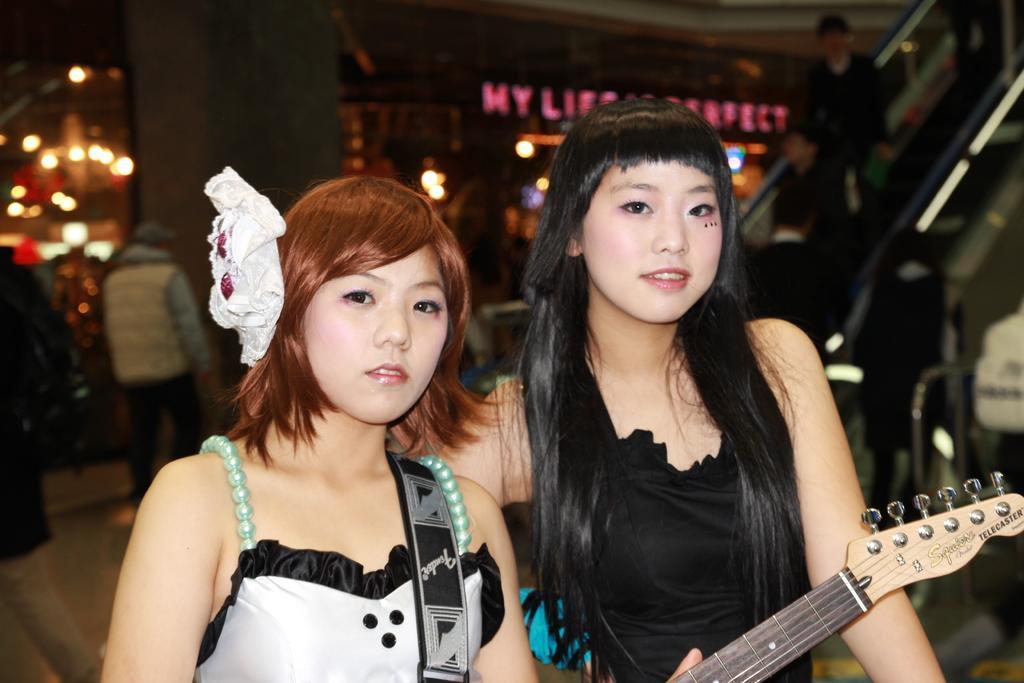Could you give a brief overview of what you see in this image? The women wearing white dress is holding a guitar in her hand and there is another woman standing beside her and there are group of people behind her. 